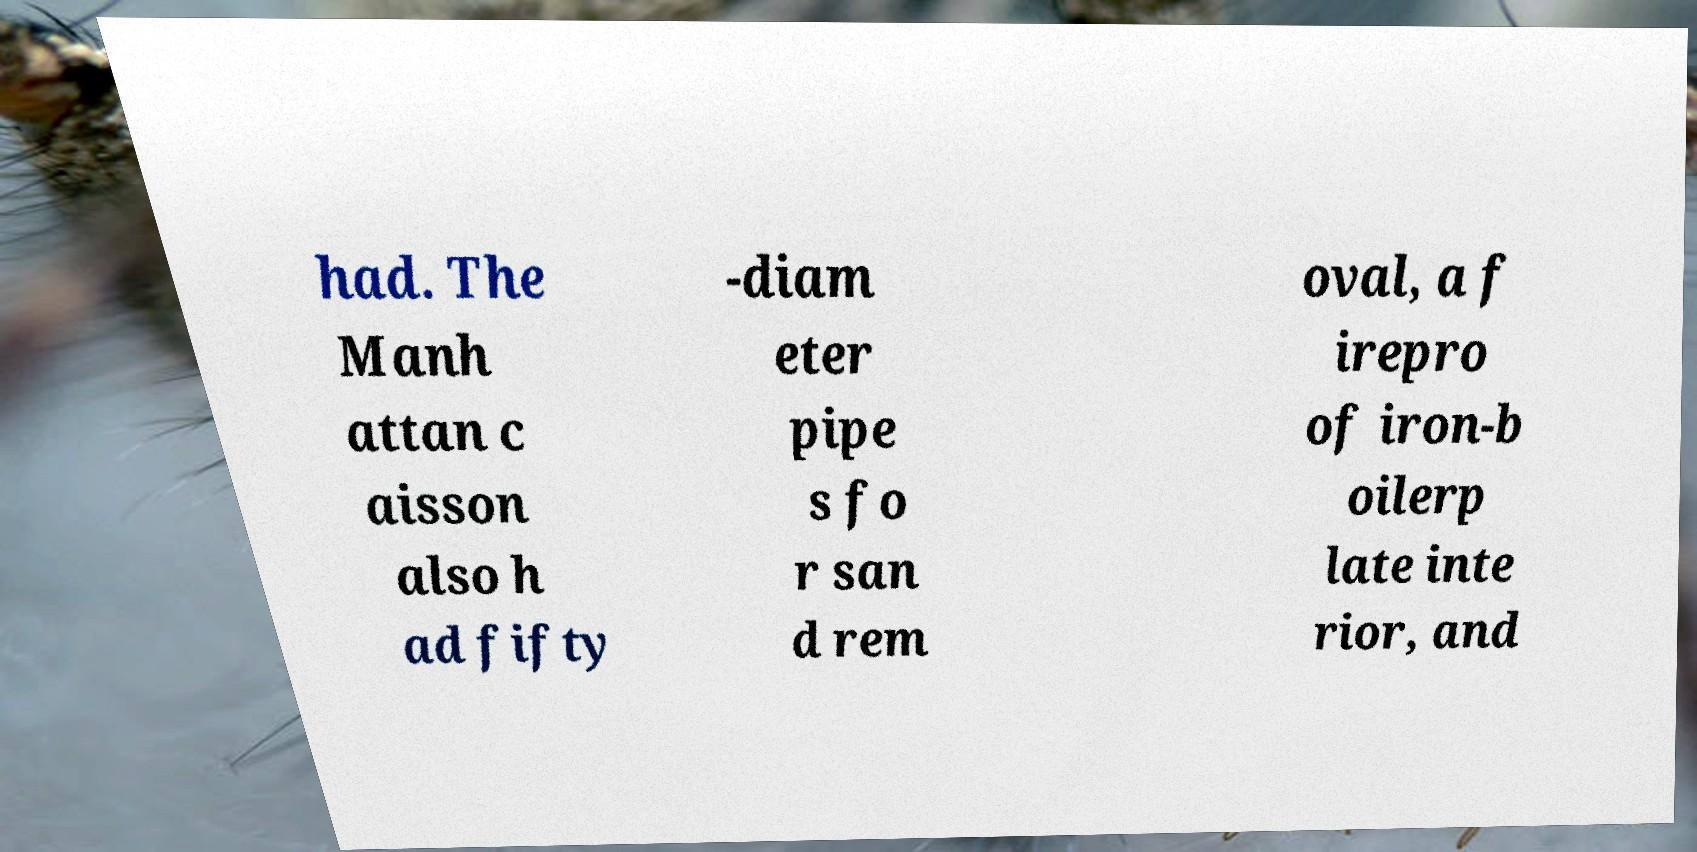For documentation purposes, I need the text within this image transcribed. Could you provide that? had. The Manh attan c aisson also h ad fifty -diam eter pipe s fo r san d rem oval, a f irepro of iron-b oilerp late inte rior, and 